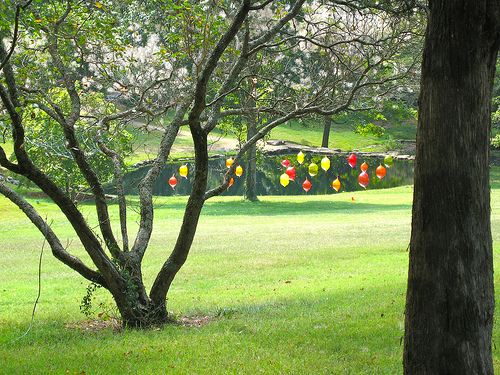<image>
Can you confirm if the tree is on the pond? No. The tree is not positioned on the pond. They may be near each other, but the tree is not supported by or resting on top of the pond. 